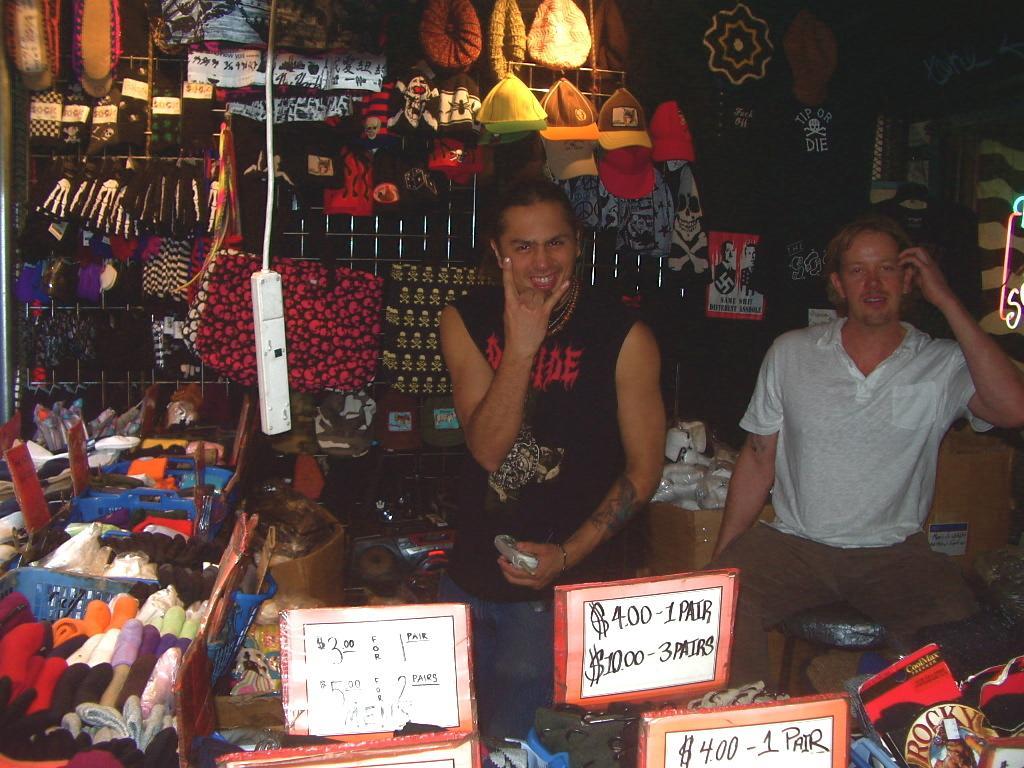Could you give a brief overview of what you see in this image? In this image there are two persons are sitting. Left side there are few baskets having few clothes and price boards in it. Background there is a metal grill having few clothes and caps hanged to it. Bottom of the image there are few baskets having price boards in it. There is a plug board hanged. 